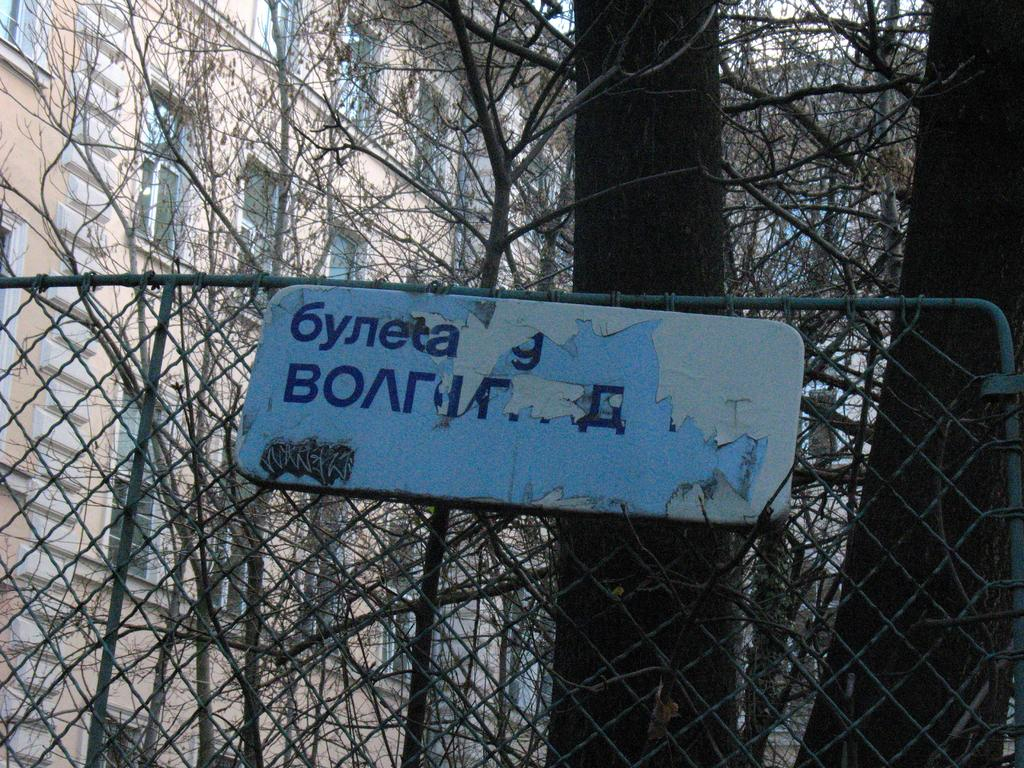What is located in the foreground of the image? There is a board in the foreground of the image. What type of natural elements can be seen in the image? Trees are visible in the image. What type of man-made structures can be seen in the background of the image? There are buildings in the background of the image. How many windows are visible on the left side of the image? There are many windows on the left side of the image. Can you see any turkeys or chickens in the image? There are no turkeys or chickens present in the image. What type of road can be seen in the image? There is no road visible in the image. 